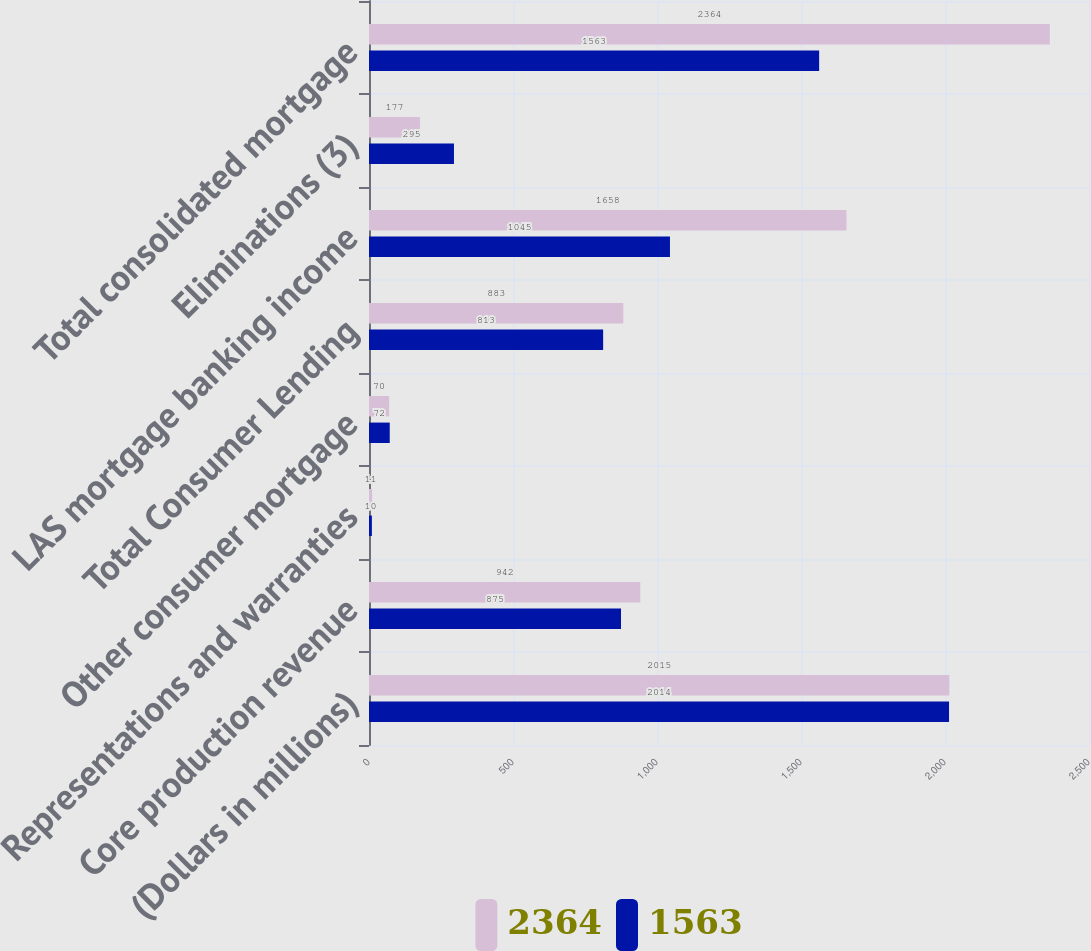<chart> <loc_0><loc_0><loc_500><loc_500><stacked_bar_chart><ecel><fcel>(Dollars in millions)<fcel>Core production revenue<fcel>Representations and warranties<fcel>Other consumer mortgage<fcel>Total Consumer Lending<fcel>LAS mortgage banking income<fcel>Eliminations (3)<fcel>Total consolidated mortgage<nl><fcel>2364<fcel>2015<fcel>942<fcel>11<fcel>70<fcel>883<fcel>1658<fcel>177<fcel>2364<nl><fcel>1563<fcel>2014<fcel>875<fcel>10<fcel>72<fcel>813<fcel>1045<fcel>295<fcel>1563<nl></chart> 